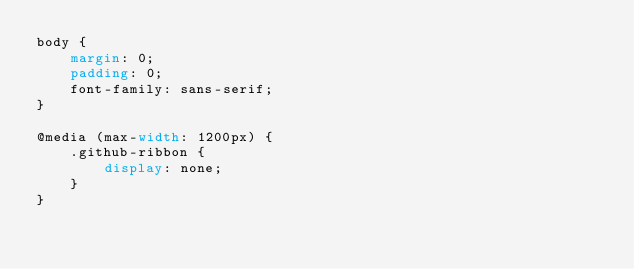<code> <loc_0><loc_0><loc_500><loc_500><_CSS_>body {
    margin: 0;
    padding: 0;
    font-family: sans-serif;
}

@media (max-width: 1200px) {
    .github-ribbon {
        display: none;
    }
}
</code> 